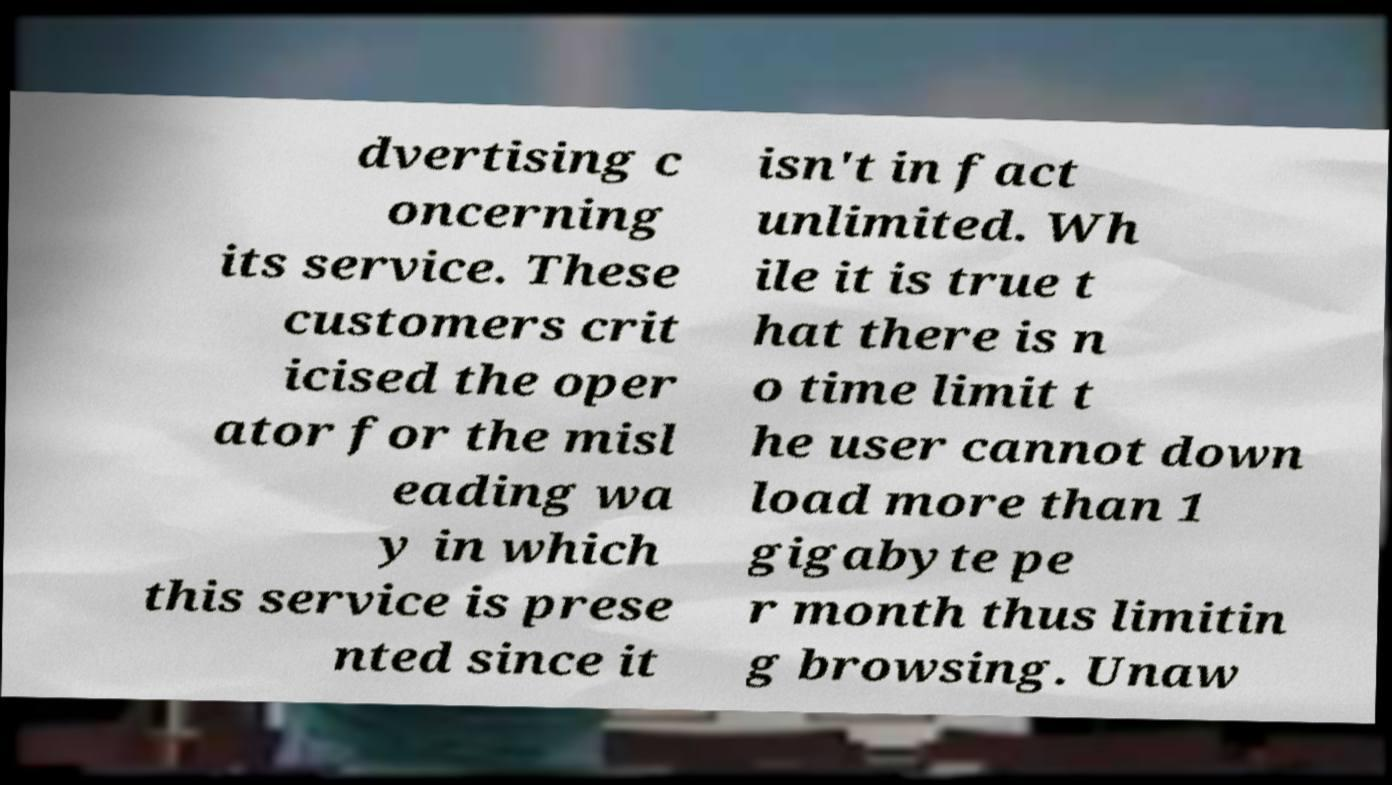There's text embedded in this image that I need extracted. Can you transcribe it verbatim? dvertising c oncerning its service. These customers crit icised the oper ator for the misl eading wa y in which this service is prese nted since it isn't in fact unlimited. Wh ile it is true t hat there is n o time limit t he user cannot down load more than 1 gigabyte pe r month thus limitin g browsing. Unaw 